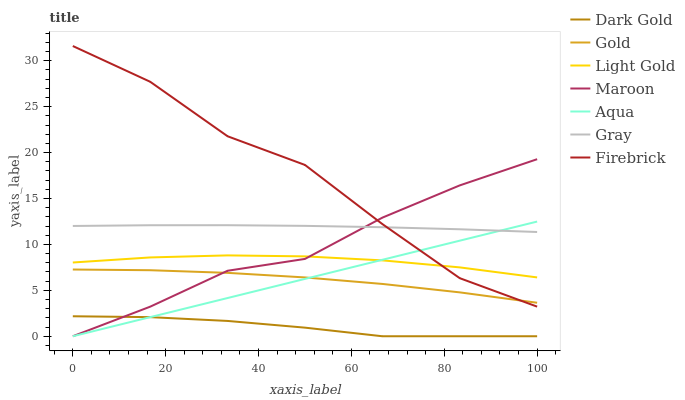Does Dark Gold have the minimum area under the curve?
Answer yes or no. Yes. Does Firebrick have the maximum area under the curve?
Answer yes or no. Yes. Does Gold have the minimum area under the curve?
Answer yes or no. No. Does Gold have the maximum area under the curve?
Answer yes or no. No. Is Aqua the smoothest?
Answer yes or no. Yes. Is Firebrick the roughest?
Answer yes or no. Yes. Is Gold the smoothest?
Answer yes or no. No. Is Gold the roughest?
Answer yes or no. No. Does Dark Gold have the lowest value?
Answer yes or no. Yes. Does Gold have the lowest value?
Answer yes or no. No. Does Firebrick have the highest value?
Answer yes or no. Yes. Does Gold have the highest value?
Answer yes or no. No. Is Dark Gold less than Gold?
Answer yes or no. Yes. Is Light Gold greater than Dark Gold?
Answer yes or no. Yes. Does Gold intersect Aqua?
Answer yes or no. Yes. Is Gold less than Aqua?
Answer yes or no. No. Is Gold greater than Aqua?
Answer yes or no. No. Does Dark Gold intersect Gold?
Answer yes or no. No. 